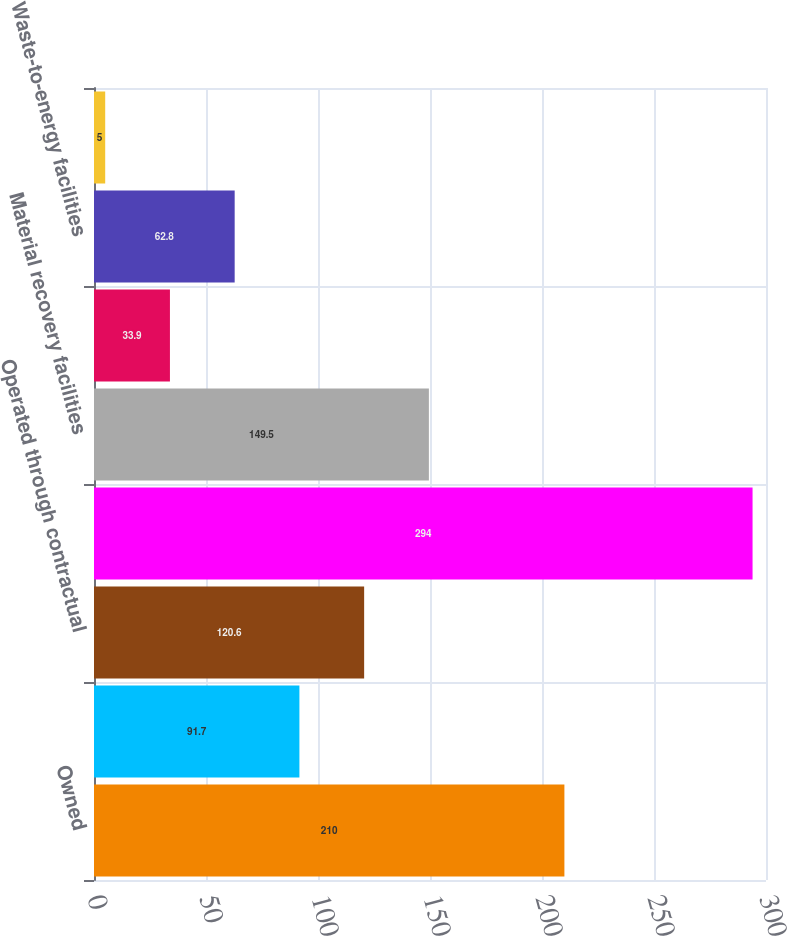<chart> <loc_0><loc_0><loc_500><loc_500><bar_chart><fcel>Owned<fcel>Operated through lease<fcel>Operated through contractual<fcel>Transfer stations<fcel>Material recovery facilities<fcel>Secondary processing<fcel>Waste-to-energy facilities<fcel>Independent power production<nl><fcel>210<fcel>91.7<fcel>120.6<fcel>294<fcel>149.5<fcel>33.9<fcel>62.8<fcel>5<nl></chart> 